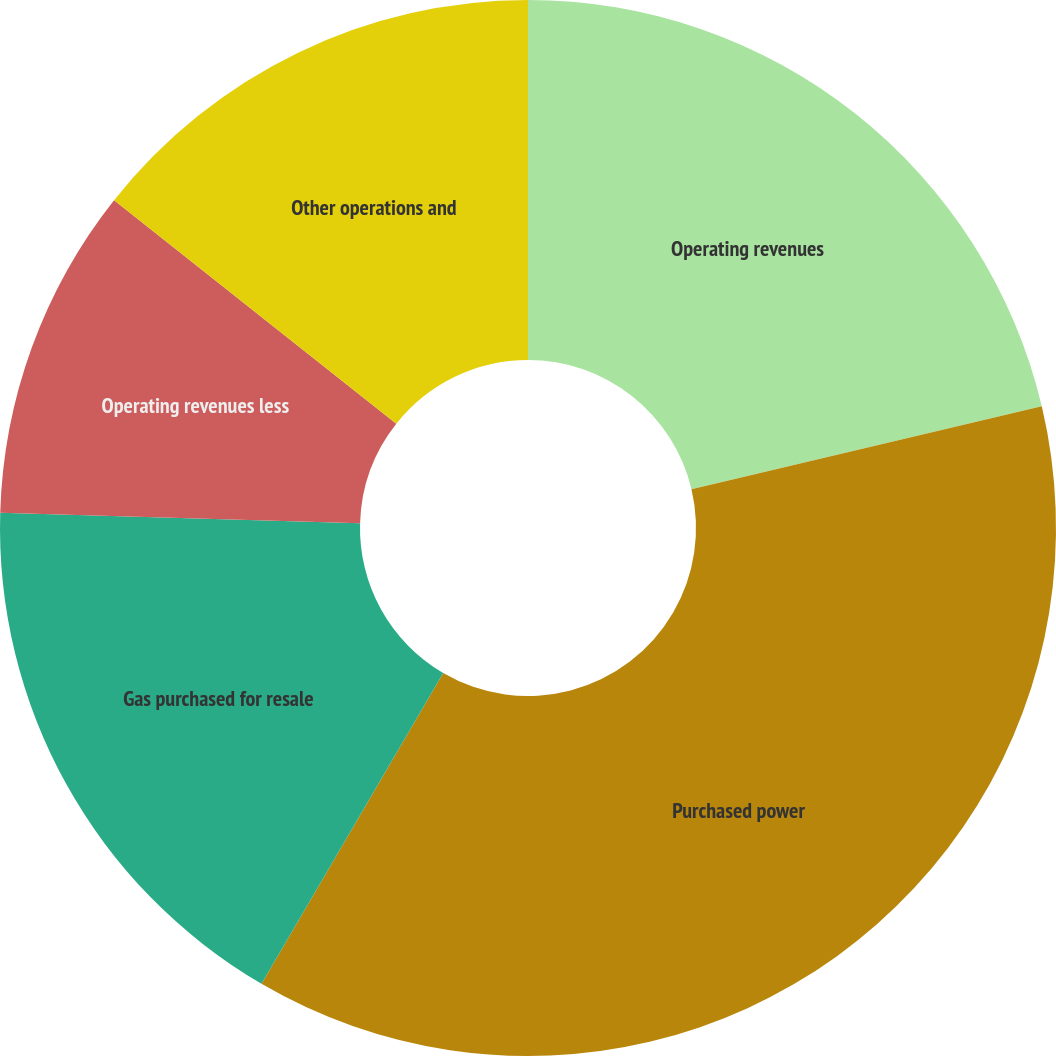Convert chart. <chart><loc_0><loc_0><loc_500><loc_500><pie_chart><fcel>Operating revenues<fcel>Purchased power<fcel>Gas purchased for resale<fcel>Operating revenues less<fcel>Other operations and<nl><fcel>21.3%<fcel>37.12%<fcel>17.04%<fcel>10.2%<fcel>14.34%<nl></chart> 